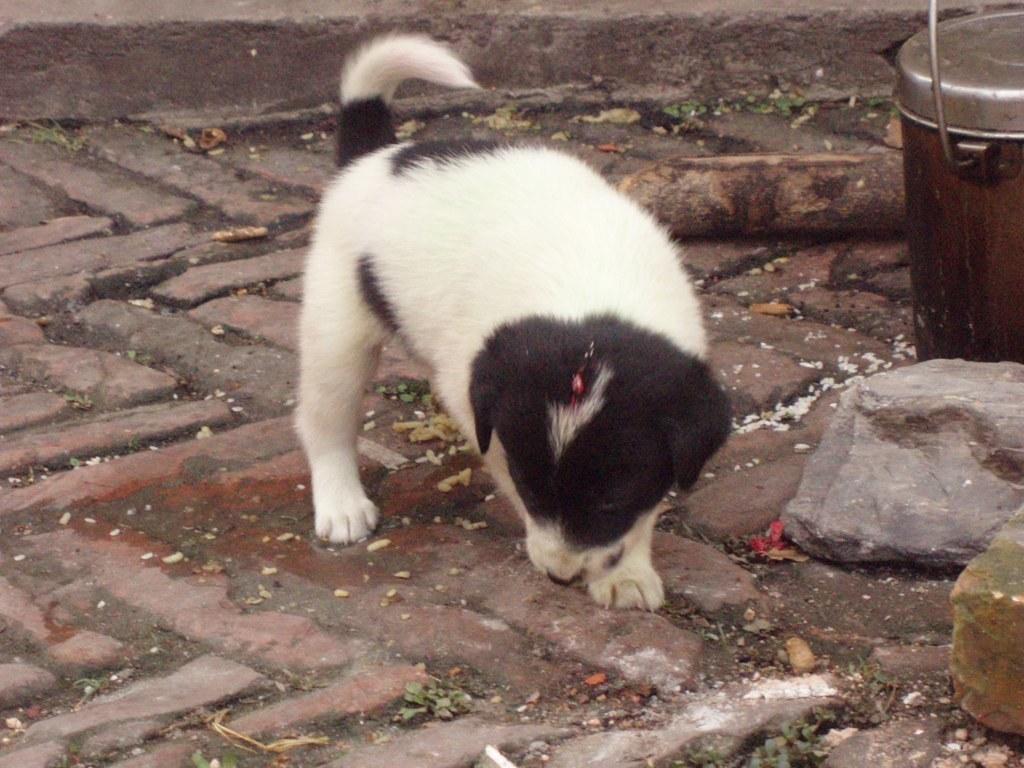How would you summarize this image in a sentence or two? In the image we can see there is a puppy standing on the ground, beside there is a can and there are rocks kept on the ground. The puppy is in black and white colour. 